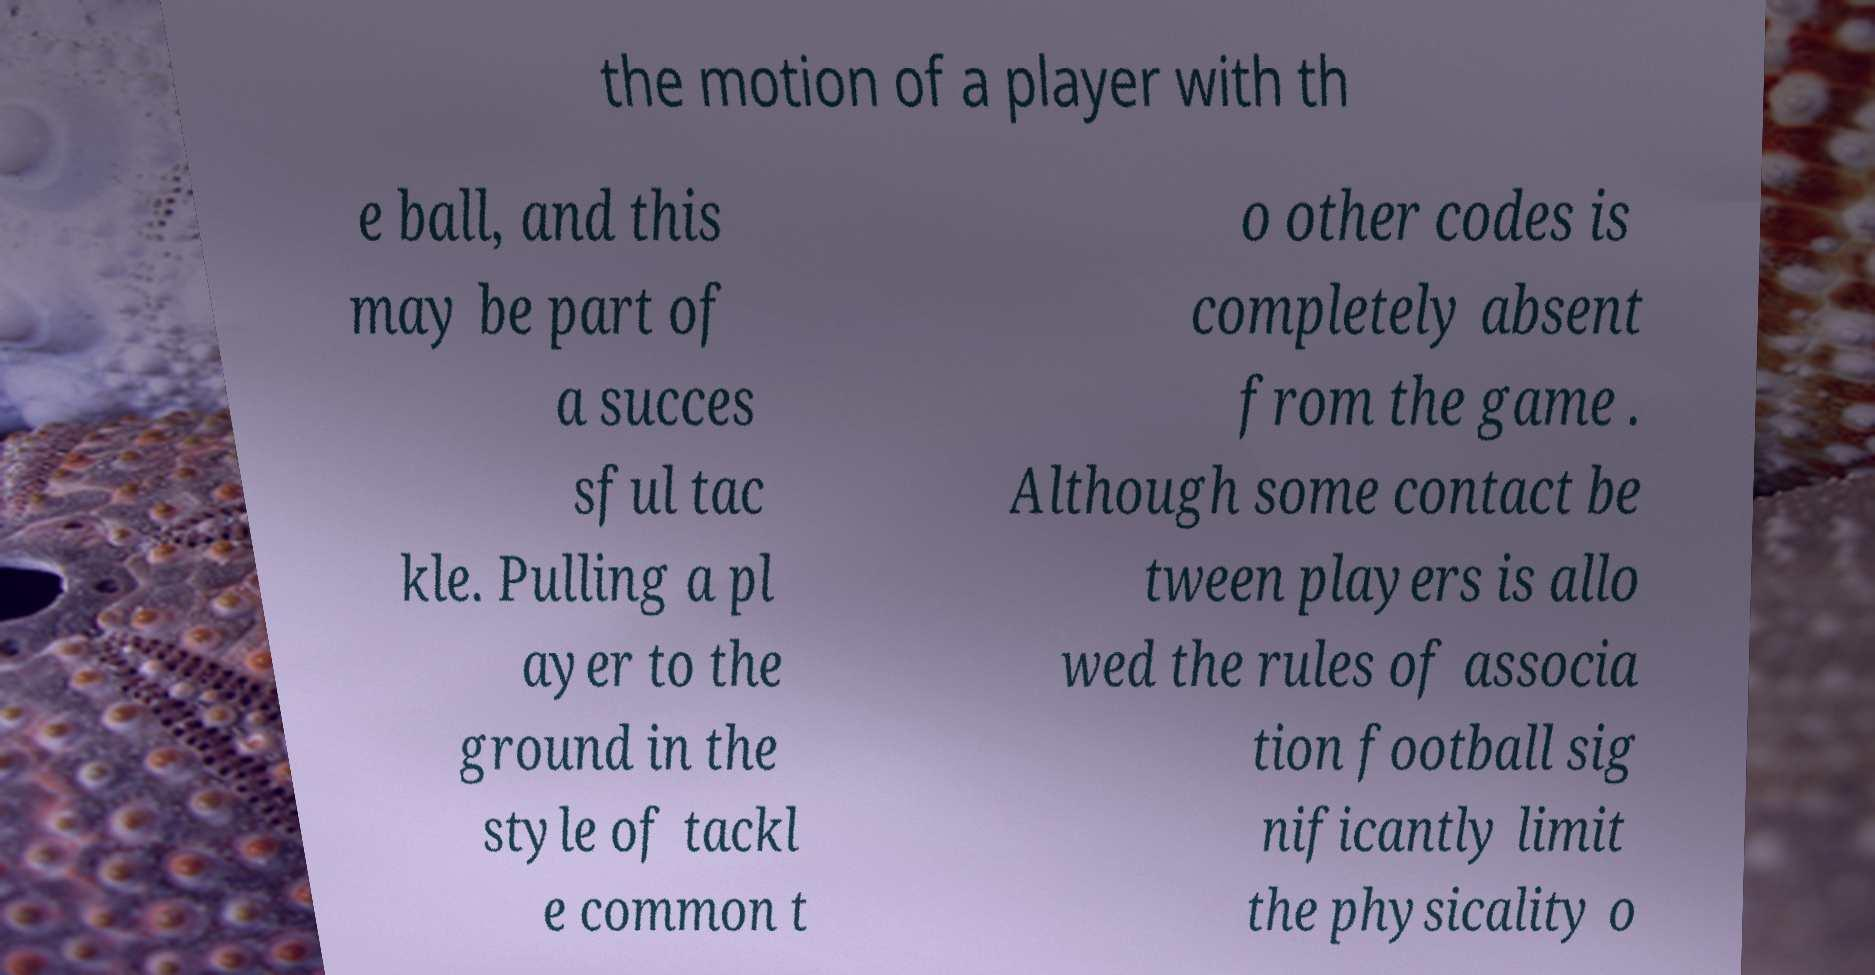There's text embedded in this image that I need extracted. Can you transcribe it verbatim? the motion of a player with th e ball, and this may be part of a succes sful tac kle. Pulling a pl ayer to the ground in the style of tackl e common t o other codes is completely absent from the game . Although some contact be tween players is allo wed the rules of associa tion football sig nificantly limit the physicality o 